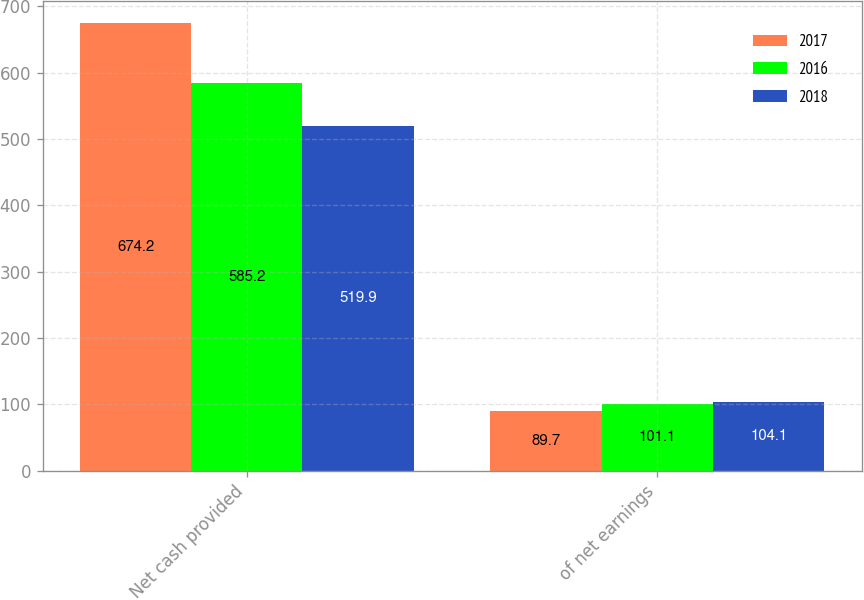<chart> <loc_0><loc_0><loc_500><loc_500><stacked_bar_chart><ecel><fcel>Net cash provided<fcel>of net earnings<nl><fcel>2017<fcel>674.2<fcel>89.7<nl><fcel>2016<fcel>585.2<fcel>101.1<nl><fcel>2018<fcel>519.9<fcel>104.1<nl></chart> 